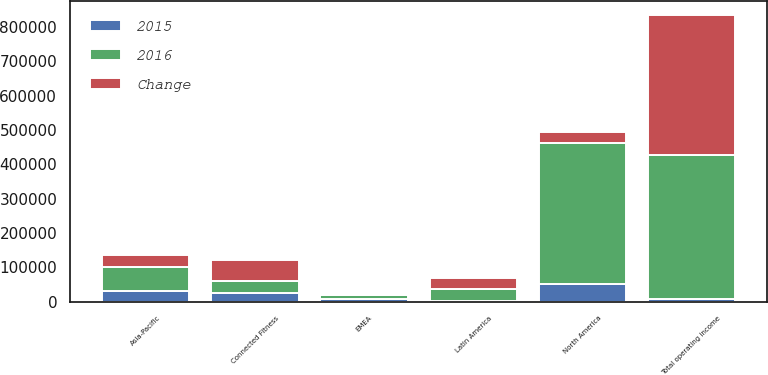Convert chart. <chart><loc_0><loc_0><loc_500><loc_500><stacked_bar_chart><ecel><fcel>North America<fcel>EMEA<fcel>Asia-Pacific<fcel>Latin America<fcel>Connected Fitness<fcel>Total operating income<nl><fcel>2016<fcel>408424<fcel>11420<fcel>68338<fcel>33891<fcel>36820<fcel>417471<nl><fcel>Change<fcel>33891<fcel>3122<fcel>36358<fcel>30593<fcel>61301<fcel>408547<nl><fcel>2015<fcel>52537<fcel>8298<fcel>31980<fcel>3298<fcel>24481<fcel>8924<nl></chart> 